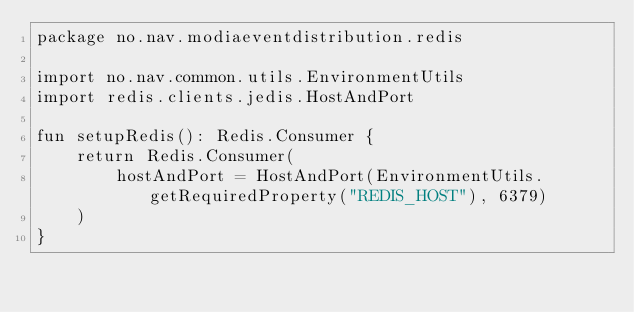<code> <loc_0><loc_0><loc_500><loc_500><_Kotlin_>package no.nav.modiaeventdistribution.redis

import no.nav.common.utils.EnvironmentUtils
import redis.clients.jedis.HostAndPort

fun setupRedis(): Redis.Consumer {
    return Redis.Consumer(
        hostAndPort = HostAndPort(EnvironmentUtils.getRequiredProperty("REDIS_HOST"), 6379)
    )
}</code> 